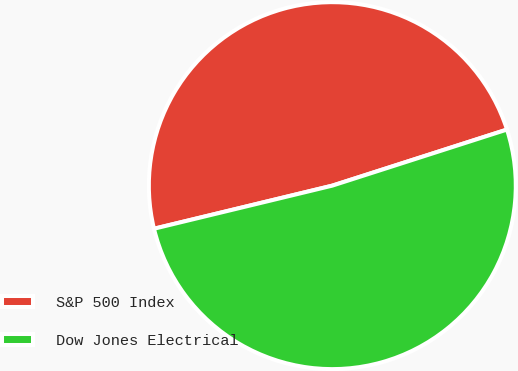<chart> <loc_0><loc_0><loc_500><loc_500><pie_chart><fcel>S&P 500 Index<fcel>Dow Jones Electrical<nl><fcel>48.83%<fcel>51.17%<nl></chart> 